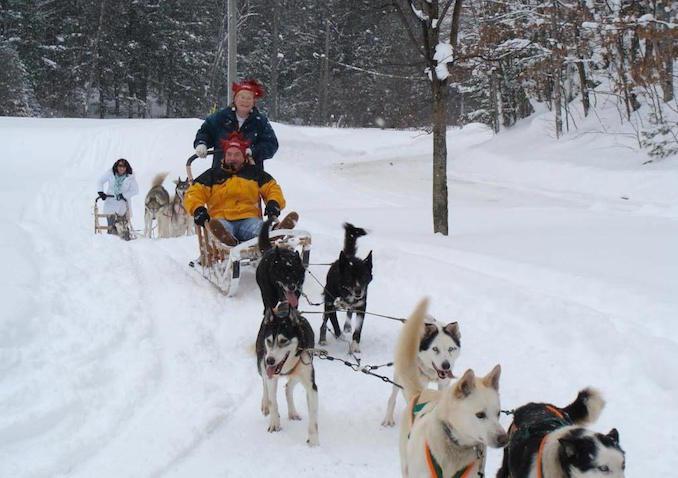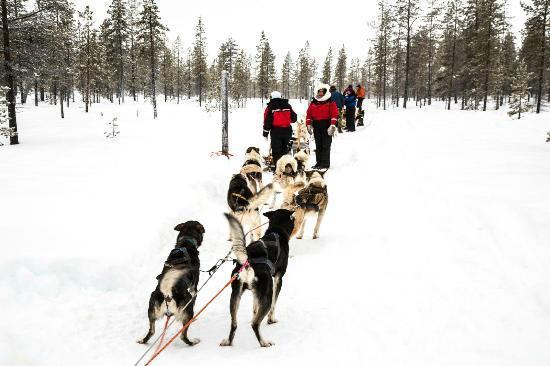The first image is the image on the left, the second image is the image on the right. Assess this claim about the two images: "At least one of the images shows a predominately black dog with white accents wearing a bright red harness on its body.". Correct or not? Answer yes or no. No. The first image is the image on the left, the second image is the image on the right. Examine the images to the left and right. Is the description "One image shows people riding the dogsled, the other does not." accurate? Answer yes or no. Yes. 